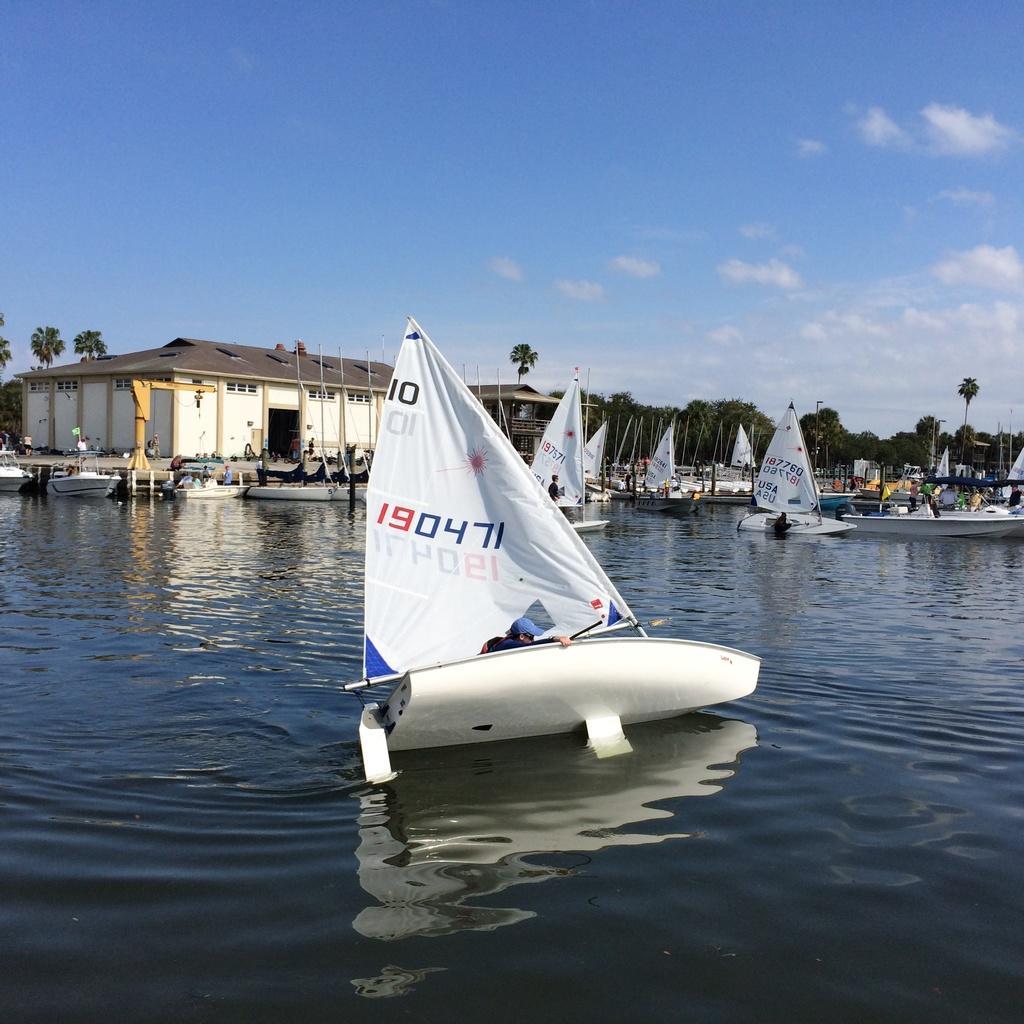How would you summarize this image in a sentence or two? In this image, we can see a few people. Among them, some people are sailing boats. We can see a few houses, trees, poles. We can see the sky with clouds. We can also see some objects. 